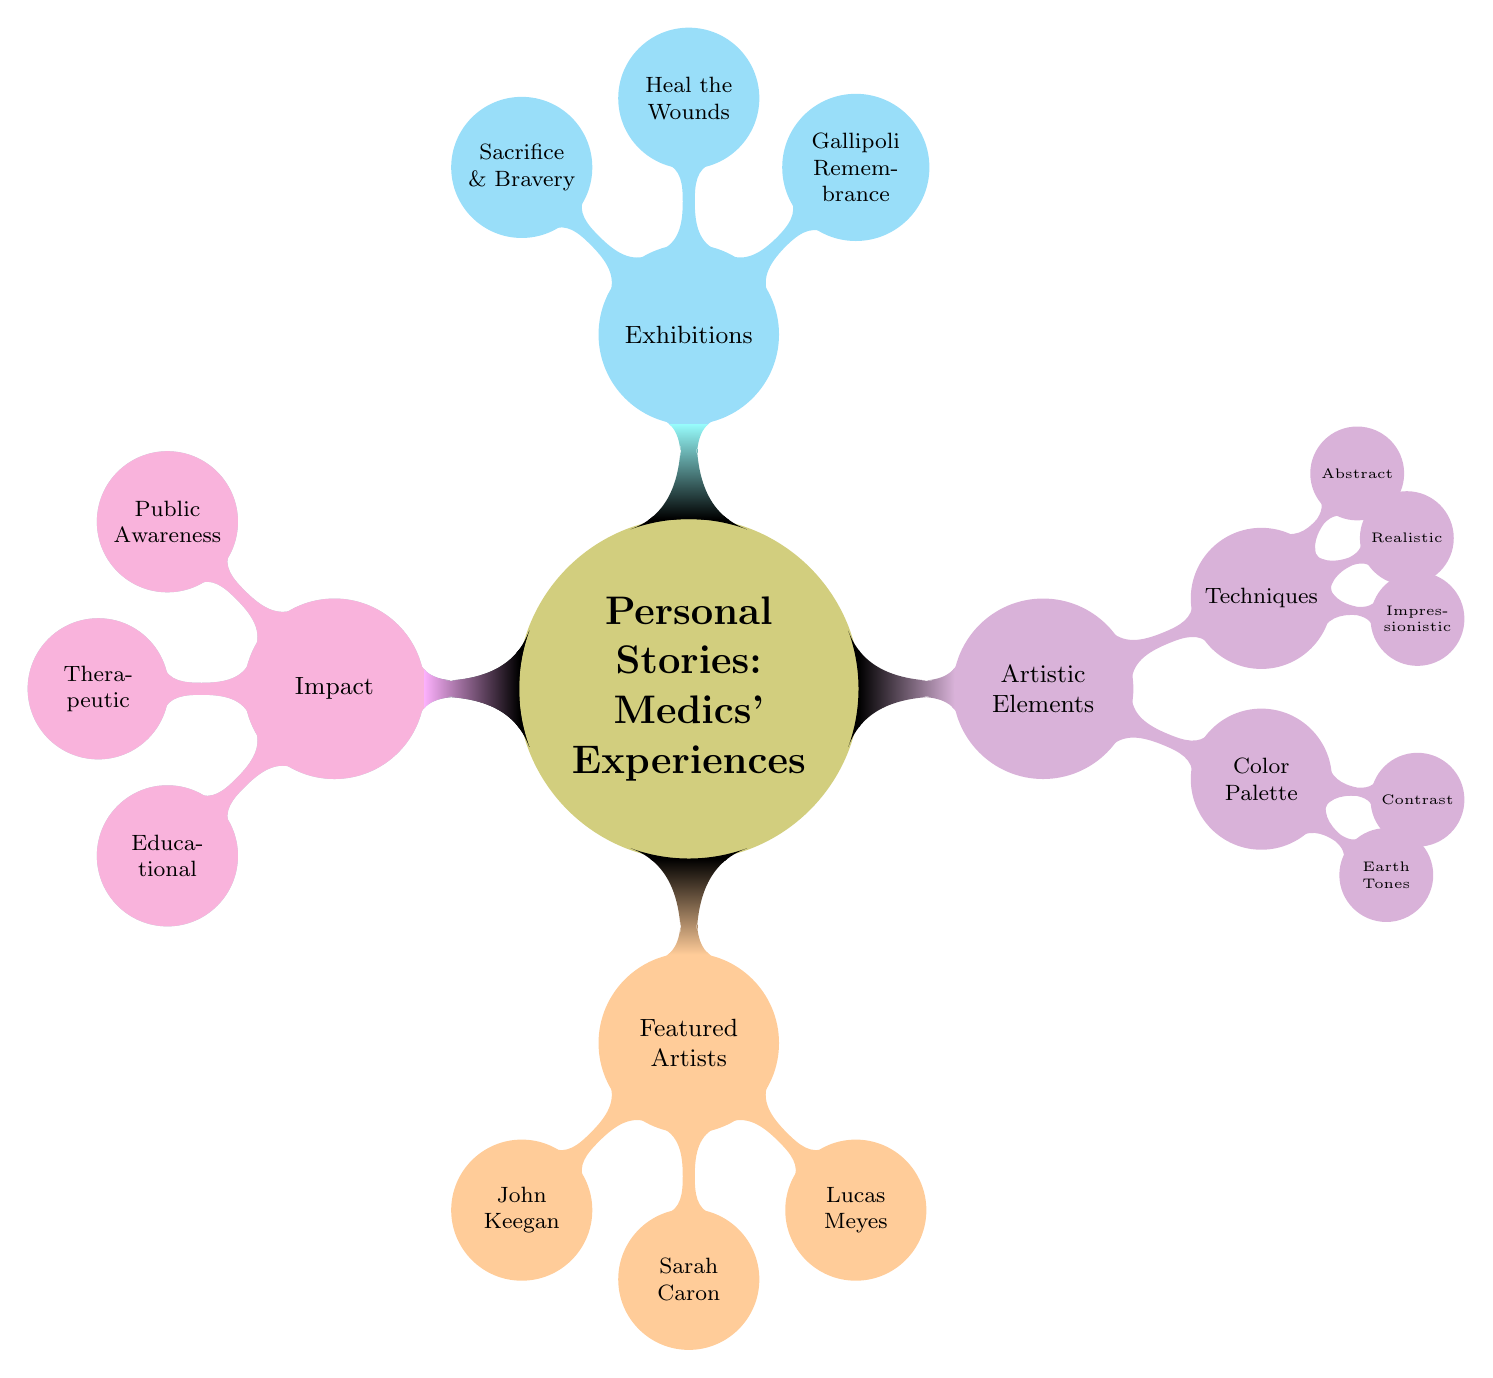What is the main theme of the mind map? The central node 'Personal Stories: Medics' Experiences' clearly defines the primary focus of the mind map. It emphasizes the experiences of medics as captured through various artistic expressions on canvas.
Answer: Medics' Experiences How many featured artists are listed in the diagram? By counting the nodes under the 'Featured Artists' section, we see John Keegan, Sarah Caron, and Lucas Meyes. This amounts to a total of three individual artists presented.
Answer: 3 Which artistic technique focuses on emotion and atmosphere? The 'Techniques' list features three categories. Under these, 'Impressionistic' is specifically noted as focusing on capturing emotion and atmosphere rather than realistic detail.
Answer: Impressionistic What color palette is prominently used in the artworks? Within the 'Artistic Elements' section, 'Color Palette' is defined, including 'Earth Tones' and 'Contrast.' Earth tones are characterized in particular as the primary palette emphasized.
Answer: Earth Tones What impact does the artwork have on public awareness? The path leads from 'Impact' to 'Public Awareness,' indicating that the artworks play a significant role in raising consciousness about the human costs of war, highlighting their importance as educational tools.
Answer: Raising Consciousness Which exhibition is dedicated to remembrance of soldiers? The node 'Gallipoli Remembrance' is a specific exhibition highlighted in the 'Exhibitions' section of the mind map, aimed at honoring and remembering those who served.
Answer: Gallipoli Remembrance What story themes are highlighted as sources of inspiration for the artwork? The 'Inspiration' node branches out into three key themes: 'Battlefield Memories,' 'Human Resilience,' and 'Comradeship,' illustrating the diverse narratives that inform the artists' works.
Answer: Battlefield Memories, Human Resilience, Comradeship Which artist is known for military medic artworks? Under the node 'Featured Artists,' John Keegan is specifically noted for having a renowned reputation in military medic artworks, distinguishing him from other artists in the list.
Answer: John Keegan What is the therapeutic impact of the artwork? Under 'Impact,' 'Therapeutic' is mentioned, indicating that the artworks serve as a healing process for both veterans and medics, underscoring art's role in mental health recovery.
Answer: Healing for Veterans and Medics 